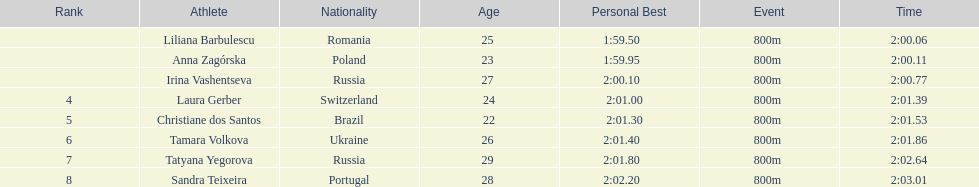I'm looking to parse the entire table for insights. Could you assist me with that? {'header': ['Rank', 'Athlete', 'Nationality', 'Age', 'Personal Best', 'Event', 'Time'], 'rows': [['', 'Liliana Barbulescu', 'Romania', '25 ', '1:59.50     ', '800m ', '2:00.06'], ['', 'Anna Zagórska', 'Poland', '23 ', '1:59.95     ', '800m ', '2:00.11'], ['', 'Irina Vashentseva', 'Russia', '27 ', '2:00.10     ', '800m ', '2:00.77'], ['4', 'Laura Gerber', 'Switzerland', '24', '2:01.00   ', '800m ', '2:01.39'], ['5', 'Christiane dos Santos', 'Brazil', '22', '2:01.30   ', '800m ', '2:01.53'], ['6', 'Tamara Volkova', 'Ukraine', '26 ', '2:01.40     ', '800m ', '2:01.86'], ['7', 'Tatyana Yegorova', 'Russia', '29 ', '2:01.80     ', '800m ', '2:02.64'], ['8', 'Sandra Teixeira', 'Portugal', '28 ', '2:02.20     ', '800m ', '2:03.01']]} Which country had the most finishers in the top 8? Russia. 